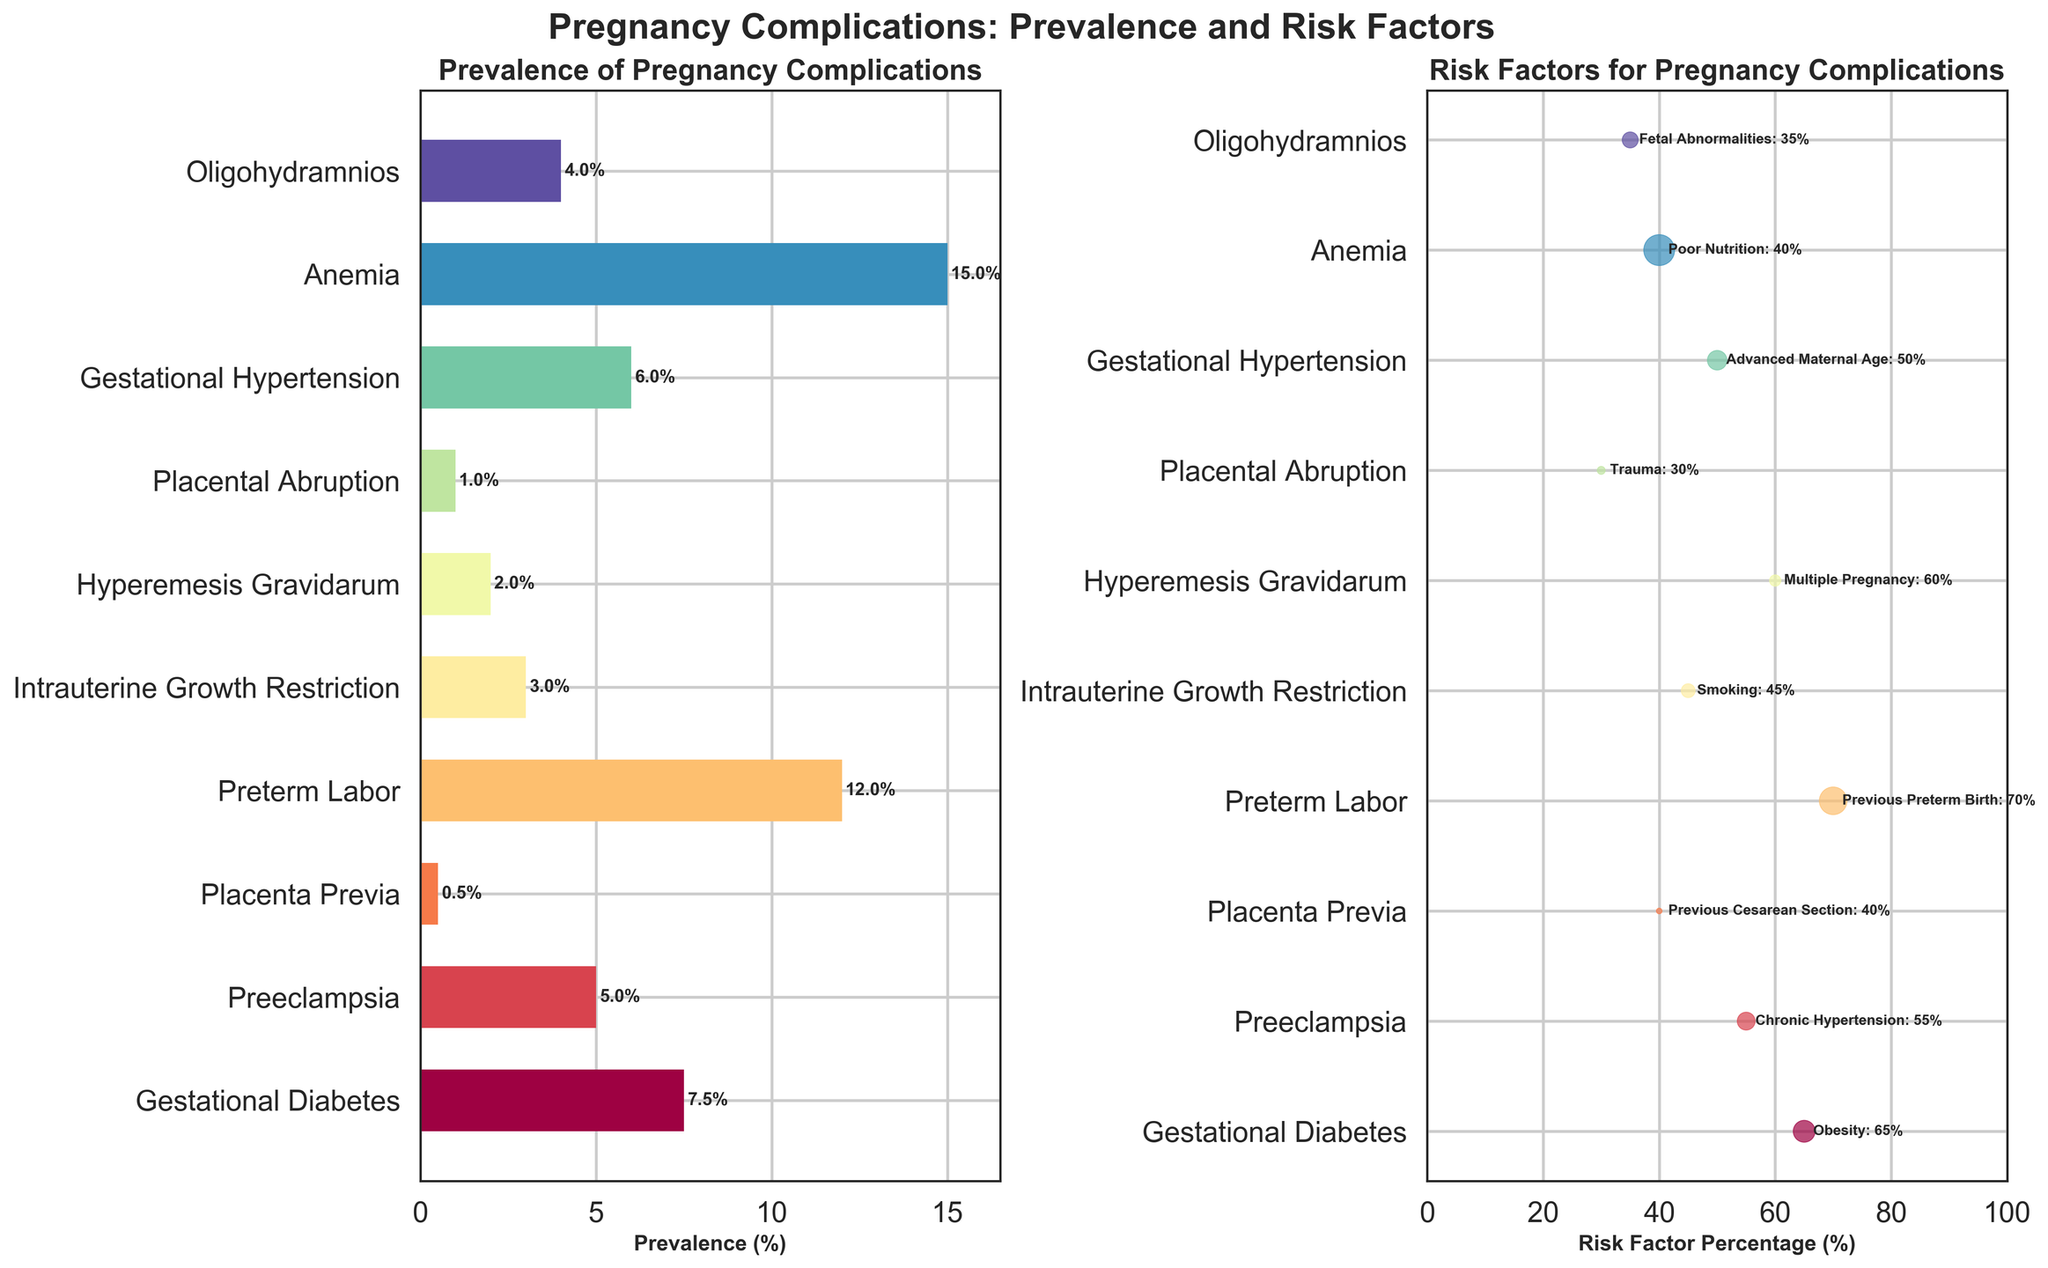What is the most common pregnancy complication based on the prevalence bar chart? The first subplot shows bars representing the prevalence of various pregnancy complications. The tallest bar indicates the most common complication. The longest bar corresponds to "Anemia" with a prevalence of 15.0%.
Answer: Anemia Which risk factor has a percentage higher than 60% as shown in the risk factor scatter plot? From the scatter plot, identify the points located to the right of the 60% mark on the x-axis. Only the complications linked to Obesity (65%), Previous Preterm Birth (70%), and Multiple Pregnancy (60%) fit this criterion.
Answer: Obesity and Previous Preterm Birth How many pregnancy complications have a prevalence greater than 10%? In the prevalence subplot, count the number of bars that extend beyond the 10% mark on the x-axis. Only "Preterm Labor" (12.0%) and "Anemia" (15.0%) have a prevalence greater than 10%.
Answer: 2 What is the risk factor percentage for hyperemesis gravidarum? Locate "Hyperemesis Gravidarum" on the scatter plot and look at the associated risk factor percentage. The label indicates Multiple Pregnancy (60%).
Answer: 60% What pregnancy complication has the lowest prevalence? On the bar chart, identify the shortest bar which indicates the lowest prevalence. The smallest bar corresponds to "Placenta Previa" with a prevalence of 0.5%.
Answer: Placenta Previa Which complication is associated with advanced maternal age and what is its prevalence? Reference the scatter plot to find the label "Advanced Maternal Age," then identify the corresponding complication and check the prevalence in the bar chart or scatter plot's marker size. The complication is "Gestational Hypertension" with a prevalence of 6.0%.
Answer: Gestational Hypertension, 6.0% Compare the prevalence of preeclampsia and intrauterine growth restriction. Which one is higher? Observe both Preeclampsia and Intrauterine Growth Restriction bars in the prevalence subplot. Preeclampsia has a prevalence of 5.0% while Intrauterine Growth Restriction has 3.0%. Hence, Preeclampsia has a higher prevalence.
Answer: Preeclampsia What is the total prevalence of all complications combined? Add the prevalence values for all listed complications: 7.5 + 5.0 + 0.5 + 12.0 + 3.0 + 2.0 + 1.0 + 6.0 + 15.0 + 4.0 = 56.0%.
Answer: 56.0% Which complication is represented by the largest marker in the risk factors scatter plot? In the scatter plot, the marker size corresponds to prevalence. The largest marker represents "Anemia" which has the highest prevalence of 15.0%.
Answer: Anemia What risk factor is associated with trauma and how does its prevalence compare to placental abruption? The scatter plot connects "Placental Abruption" with "Trauma" (30%). In the prevalence subplot, "Placental Abruption" has a prevalence of 1.0%. So the factor associated with trauma is Placental Abruption with 1.0% prevalence.
Answer: Placental Abruption, 1.0% 